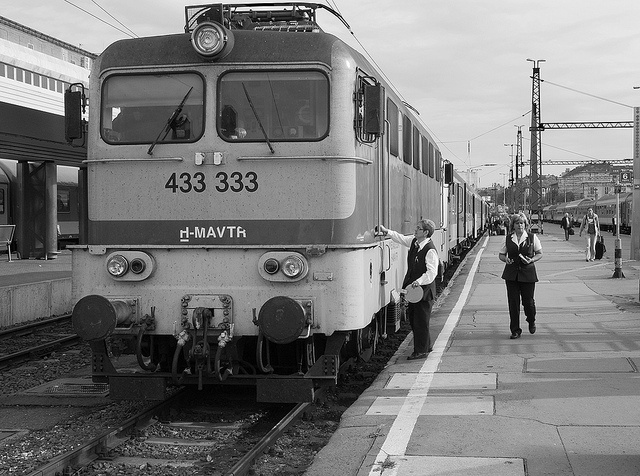Describe the objects in this image and their specific colors. I can see train in lightgray, gray, and black tones, people in lightgray, black, darkgray, and gray tones, people in lightgray, black, gray, and darkgray tones, train in lightgray, black, and gray tones, and train in lightgray, gray, and black tones in this image. 